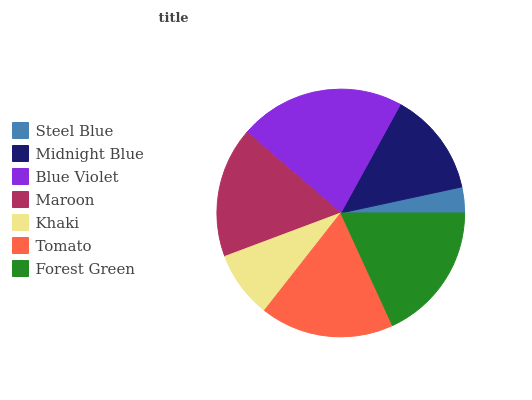Is Steel Blue the minimum?
Answer yes or no. Yes. Is Blue Violet the maximum?
Answer yes or no. Yes. Is Midnight Blue the minimum?
Answer yes or no. No. Is Midnight Blue the maximum?
Answer yes or no. No. Is Midnight Blue greater than Steel Blue?
Answer yes or no. Yes. Is Steel Blue less than Midnight Blue?
Answer yes or no. Yes. Is Steel Blue greater than Midnight Blue?
Answer yes or no. No. Is Midnight Blue less than Steel Blue?
Answer yes or no. No. Is Maroon the high median?
Answer yes or no. Yes. Is Maroon the low median?
Answer yes or no. Yes. Is Khaki the high median?
Answer yes or no. No. Is Midnight Blue the low median?
Answer yes or no. No. 